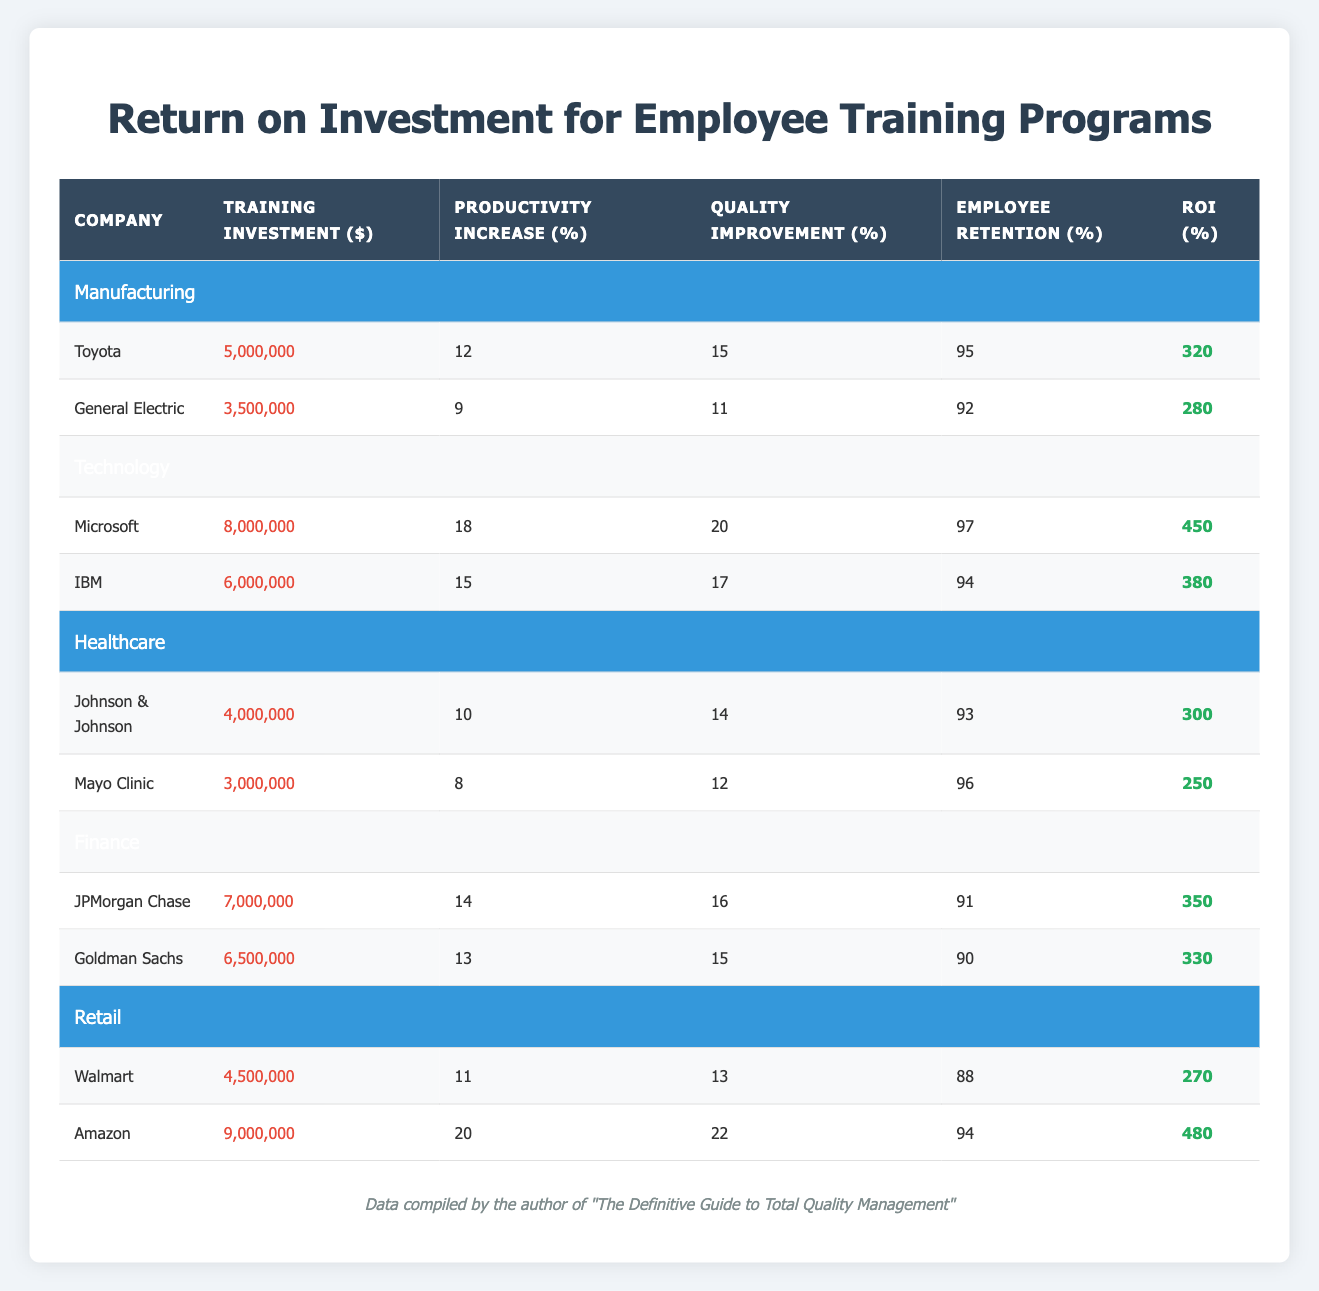What is the ROI percentage for Amazon's training program? The table lists Amazon's ROI percentage in the row corresponding to the company under the Retail industry. The value provided there is 480.
Answer: 480 Which company in the Technology industry has the highest employee retention? By looking at the employee retention percentages for, Microsoft (97%) and IBM (94%) in the Technology section, it's clear that Microsoft has the highest retention rate.
Answer: Microsoft What is the average training investment for companies in the Healthcare industry? The training investments for Johnson & Johnson and Mayo Clinic are $4,000,000 and $3,000,000, respectively. The total investment is $4,000,000 + $3,000,000 = $7,000,000. There are 2 companies, so the average is $7,000,000 / 2 = $3,500,000.
Answer: 3,500,000 Did any company in the Manufacturing industry achieve an ROI percentage over 300? The data for Toyota shows an ROI percentage of 320, which is greater than 300, while General Electric shows 280, which is not. Therefore, yes, Toyota did.
Answer: Yes What is the difference in training investment between the highest and lowest in the Finance industry? The training investment for JPMorgan Chase is $7,000,000, and for Goldman Sachs, it is $6,500,000. The difference is $7,000,000 - $6,500,000 = $500,000.
Answer: 500,000 Which industry has the company with the highest productivity increase, and what is that percentage? In the Retail industry, Amazon has the highest productivity increase at 20%. Checking the other industries, no other company has a percentage higher than this.
Answer: Retail, 20% What training investment was made by General Electric? The table clearly lists the training investment for General Electric as $3,500,000 under the Manufacturing section.
Answer: 3,500,000 Is it true that all companies in the Retail industry have an employee retention rate of 90% or higher? The employee retention rates for Walmart (88%) and Amazon (94%) show that Walmart is below 90%, making the statement false.
Answer: No 